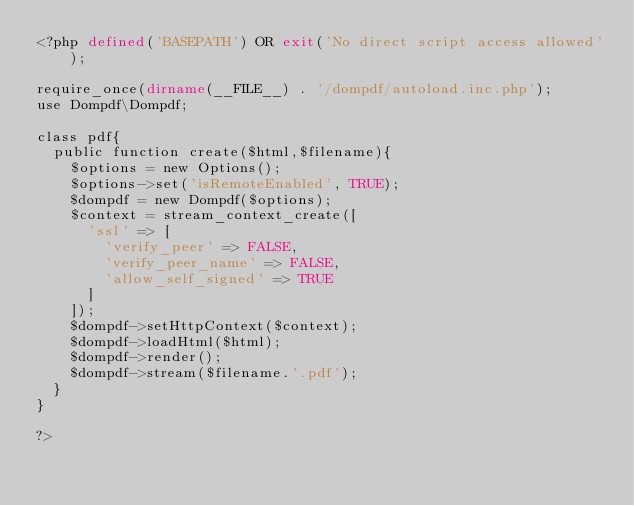<code> <loc_0><loc_0><loc_500><loc_500><_PHP_><?php defined('BASEPATH') OR exit('No direct script access allowed');

require_once(dirname(__FILE__) . '/dompdf/autoload.inc.php');
use Dompdf\Dompdf;

class pdf{
	public function create($html,$filename){
		$options = new Options();
		$options->set('isRemoteEnabled', TRUE);
		$dompdf = new Dompdf($options);
		$context = stream_context_create([
			'ssl' => [
				'verify_peer' => FALSE,
				'verify_peer_name' => FALSE,
				'allow_self_signed' => TRUE
			]
		]);
		$dompdf->setHttpContext($context);
		$dompdf->loadHtml($html);
		$dompdf->render();
		$dompdf->stream($filename.'.pdf');
	}
}

?></code> 